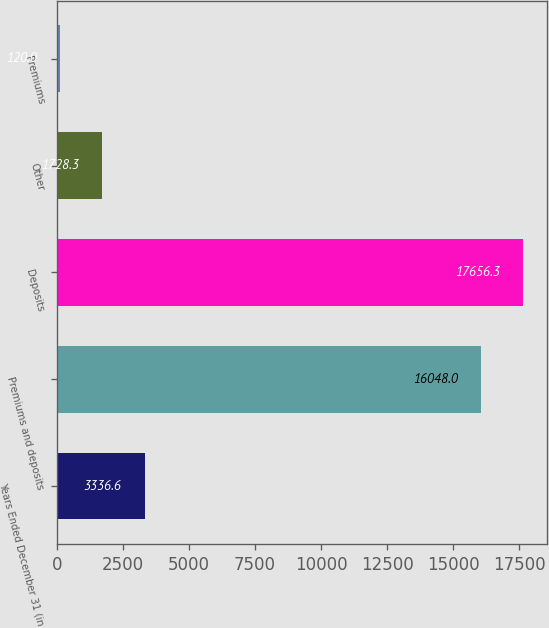Convert chart. <chart><loc_0><loc_0><loc_500><loc_500><bar_chart><fcel>Years Ended December 31 (in<fcel>Premiums and deposits<fcel>Deposits<fcel>Other<fcel>Premiums<nl><fcel>3336.6<fcel>16048<fcel>17656.3<fcel>1728.3<fcel>120<nl></chart> 